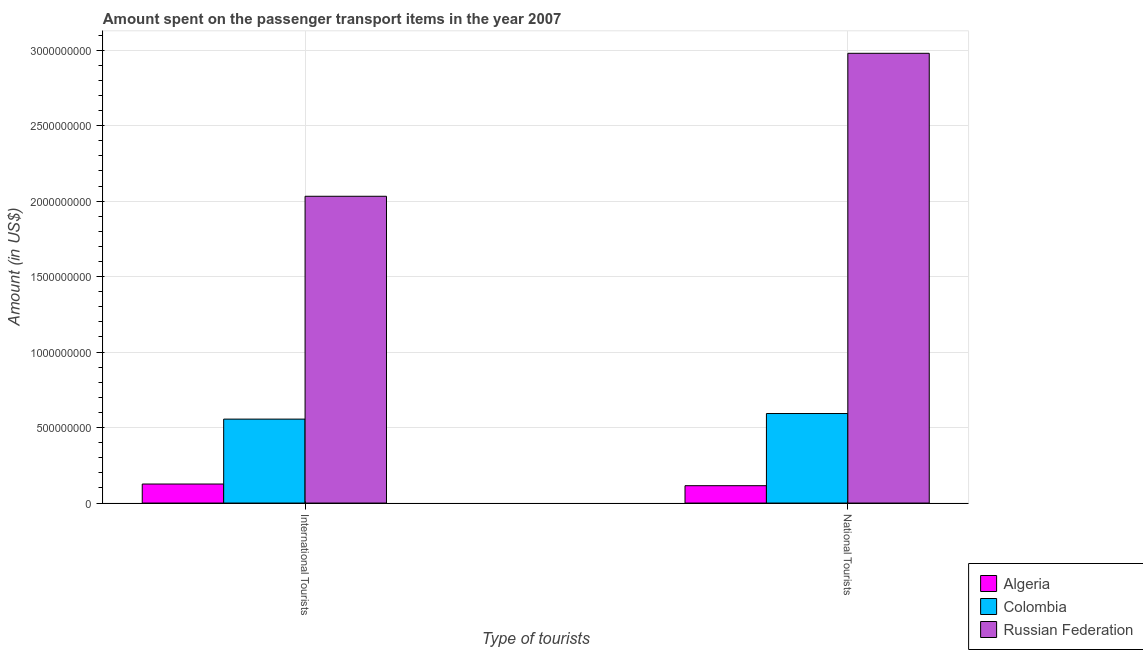How many different coloured bars are there?
Provide a short and direct response. 3. How many groups of bars are there?
Your answer should be compact. 2. Are the number of bars per tick equal to the number of legend labels?
Offer a terse response. Yes. Are the number of bars on each tick of the X-axis equal?
Provide a short and direct response. Yes. How many bars are there on the 1st tick from the right?
Provide a succinct answer. 3. What is the label of the 1st group of bars from the left?
Your answer should be compact. International Tourists. What is the amount spent on transport items of national tourists in Russian Federation?
Give a very brief answer. 2.98e+09. Across all countries, what is the maximum amount spent on transport items of international tourists?
Give a very brief answer. 2.03e+09. Across all countries, what is the minimum amount spent on transport items of national tourists?
Provide a succinct answer. 1.15e+08. In which country was the amount spent on transport items of national tourists maximum?
Keep it short and to the point. Russian Federation. In which country was the amount spent on transport items of international tourists minimum?
Offer a terse response. Algeria. What is the total amount spent on transport items of national tourists in the graph?
Your response must be concise. 3.69e+09. What is the difference between the amount spent on transport items of international tourists in Russian Federation and that in Algeria?
Ensure brevity in your answer.  1.91e+09. What is the difference between the amount spent on transport items of international tourists in Algeria and the amount spent on transport items of national tourists in Russian Federation?
Offer a very short reply. -2.85e+09. What is the average amount spent on transport items of national tourists per country?
Provide a short and direct response. 1.23e+09. What is the difference between the amount spent on transport items of international tourists and amount spent on transport items of national tourists in Russian Federation?
Provide a short and direct response. -9.47e+08. In how many countries, is the amount spent on transport items of international tourists greater than 900000000 US$?
Make the answer very short. 1. What is the ratio of the amount spent on transport items of national tourists in Russian Federation to that in Colombia?
Provide a short and direct response. 5.02. Is the amount spent on transport items of international tourists in Russian Federation less than that in Colombia?
Your answer should be very brief. No. What does the 3rd bar from the left in International Tourists represents?
Offer a very short reply. Russian Federation. What does the 1st bar from the right in National Tourists represents?
Ensure brevity in your answer.  Russian Federation. Are all the bars in the graph horizontal?
Ensure brevity in your answer.  No. Does the graph contain any zero values?
Provide a succinct answer. No. How many legend labels are there?
Your answer should be very brief. 3. How are the legend labels stacked?
Your answer should be compact. Vertical. What is the title of the graph?
Your answer should be very brief. Amount spent on the passenger transport items in the year 2007. Does "Antigua and Barbuda" appear as one of the legend labels in the graph?
Ensure brevity in your answer.  No. What is the label or title of the X-axis?
Make the answer very short. Type of tourists. What is the label or title of the Y-axis?
Your answer should be very brief. Amount (in US$). What is the Amount (in US$) in Algeria in International Tourists?
Your answer should be very brief. 1.26e+08. What is the Amount (in US$) of Colombia in International Tourists?
Give a very brief answer. 5.56e+08. What is the Amount (in US$) of Russian Federation in International Tourists?
Your response must be concise. 2.03e+09. What is the Amount (in US$) of Algeria in National Tourists?
Your answer should be very brief. 1.15e+08. What is the Amount (in US$) of Colombia in National Tourists?
Provide a succinct answer. 5.93e+08. What is the Amount (in US$) in Russian Federation in National Tourists?
Ensure brevity in your answer.  2.98e+09. Across all Type of tourists, what is the maximum Amount (in US$) of Algeria?
Offer a very short reply. 1.26e+08. Across all Type of tourists, what is the maximum Amount (in US$) of Colombia?
Provide a succinct answer. 5.93e+08. Across all Type of tourists, what is the maximum Amount (in US$) in Russian Federation?
Provide a succinct answer. 2.98e+09. Across all Type of tourists, what is the minimum Amount (in US$) of Algeria?
Your response must be concise. 1.15e+08. Across all Type of tourists, what is the minimum Amount (in US$) of Colombia?
Provide a succinct answer. 5.56e+08. Across all Type of tourists, what is the minimum Amount (in US$) of Russian Federation?
Your response must be concise. 2.03e+09. What is the total Amount (in US$) in Algeria in the graph?
Ensure brevity in your answer.  2.41e+08. What is the total Amount (in US$) of Colombia in the graph?
Keep it short and to the point. 1.15e+09. What is the total Amount (in US$) of Russian Federation in the graph?
Provide a succinct answer. 5.01e+09. What is the difference between the Amount (in US$) of Algeria in International Tourists and that in National Tourists?
Keep it short and to the point. 1.10e+07. What is the difference between the Amount (in US$) in Colombia in International Tourists and that in National Tourists?
Give a very brief answer. -3.70e+07. What is the difference between the Amount (in US$) of Russian Federation in International Tourists and that in National Tourists?
Provide a succinct answer. -9.47e+08. What is the difference between the Amount (in US$) of Algeria in International Tourists and the Amount (in US$) of Colombia in National Tourists?
Make the answer very short. -4.67e+08. What is the difference between the Amount (in US$) of Algeria in International Tourists and the Amount (in US$) of Russian Federation in National Tourists?
Keep it short and to the point. -2.85e+09. What is the difference between the Amount (in US$) of Colombia in International Tourists and the Amount (in US$) of Russian Federation in National Tourists?
Your answer should be very brief. -2.42e+09. What is the average Amount (in US$) of Algeria per Type of tourists?
Provide a short and direct response. 1.20e+08. What is the average Amount (in US$) in Colombia per Type of tourists?
Offer a very short reply. 5.74e+08. What is the average Amount (in US$) in Russian Federation per Type of tourists?
Offer a very short reply. 2.51e+09. What is the difference between the Amount (in US$) of Algeria and Amount (in US$) of Colombia in International Tourists?
Provide a succinct answer. -4.30e+08. What is the difference between the Amount (in US$) of Algeria and Amount (in US$) of Russian Federation in International Tourists?
Make the answer very short. -1.91e+09. What is the difference between the Amount (in US$) in Colombia and Amount (in US$) in Russian Federation in International Tourists?
Your answer should be very brief. -1.48e+09. What is the difference between the Amount (in US$) in Algeria and Amount (in US$) in Colombia in National Tourists?
Give a very brief answer. -4.78e+08. What is the difference between the Amount (in US$) of Algeria and Amount (in US$) of Russian Federation in National Tourists?
Your answer should be compact. -2.86e+09. What is the difference between the Amount (in US$) of Colombia and Amount (in US$) of Russian Federation in National Tourists?
Offer a terse response. -2.39e+09. What is the ratio of the Amount (in US$) in Algeria in International Tourists to that in National Tourists?
Ensure brevity in your answer.  1.1. What is the ratio of the Amount (in US$) in Colombia in International Tourists to that in National Tourists?
Provide a short and direct response. 0.94. What is the ratio of the Amount (in US$) in Russian Federation in International Tourists to that in National Tourists?
Provide a short and direct response. 0.68. What is the difference between the highest and the second highest Amount (in US$) in Algeria?
Ensure brevity in your answer.  1.10e+07. What is the difference between the highest and the second highest Amount (in US$) of Colombia?
Offer a very short reply. 3.70e+07. What is the difference between the highest and the second highest Amount (in US$) in Russian Federation?
Offer a very short reply. 9.47e+08. What is the difference between the highest and the lowest Amount (in US$) in Algeria?
Offer a terse response. 1.10e+07. What is the difference between the highest and the lowest Amount (in US$) in Colombia?
Your response must be concise. 3.70e+07. What is the difference between the highest and the lowest Amount (in US$) of Russian Federation?
Offer a terse response. 9.47e+08. 